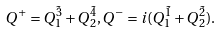Convert formula to latex. <formula><loc_0><loc_0><loc_500><loc_500>Q ^ { + } = Q _ { 1 } ^ { \tilde { 3 } } + Q _ { 2 } ^ { \tilde { 4 } } , Q ^ { - } = i ( Q _ { 1 } ^ { \tilde { 1 } } + Q _ { 2 } ^ { \tilde { 2 } } ) .</formula> 